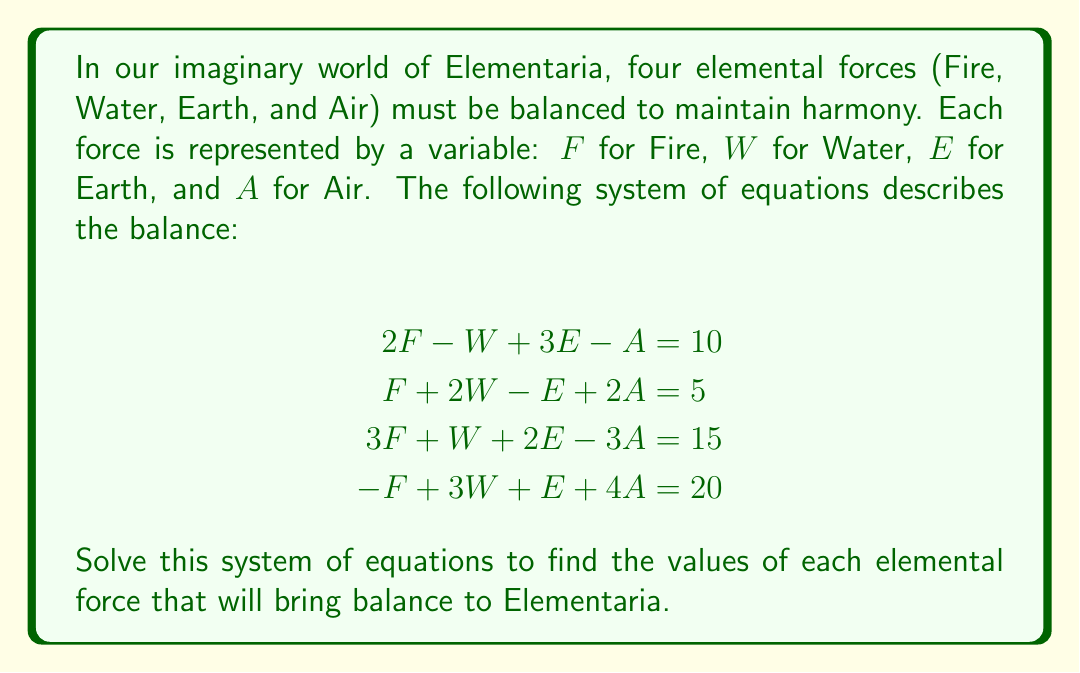Solve this math problem. Let's solve this system of equations using Gaussian elimination:

Step 1: Write the augmented matrix
$$\begin{bmatrix}
2 & -1 & 3 & -1 & 10 \\
1 & 2 & -1 & 2 & 5 \\
3 & 1 & 2 & -3 & 15 \\
-1 & 3 & 1 & 4 & 20
\end{bmatrix}$$

Step 2: Use row operations to transform the matrix into row echelon form

a) Multiply R1 by -1/2 and add to R2:
$$\begin{bmatrix}
2 & -1 & 3 & -1 & 10 \\
0 & 2.5 & -2.5 & 2.5 & 0 \\
3 & 1 & 2 & -3 & 15 \\
-1 & 3 & 1 & 4 & 20
\end{bmatrix}$$

b) Multiply R1 by -3/2 and add to R3:
$$\begin{bmatrix}
2 & -1 & 3 & -1 & 10 \\
0 & 2.5 & -2.5 & 2.5 & 0 \\
0 & 2.5 & -2.5 & -1.5 & 0 \\
-1 & 3 & 1 & 4 & 20
\end{bmatrix}$$

c) Multiply R1 by 1/2 and add to R4:
$$\begin{bmatrix}
2 & -1 & 3 & -1 & 10 \\
0 & 2.5 & -2.5 & 2.5 & 0 \\
0 & 2.5 & -2.5 & -1.5 & 0 \\
0 & 2.5 & 2.5 & 3.5 & 25
\end{bmatrix}$$

d) Multiply R2 by -1 and add to R3:
$$\begin{bmatrix}
2 & -1 & 3 & -1 & 10 \\
0 & 2.5 & -2.5 & 2.5 & 0 \\
0 & 0 & 0 & -4 & 0 \\
0 & 2.5 & 2.5 & 3.5 & 25
\end{bmatrix}$$

e) Multiply R2 by -1 and add to R4:
$$\begin{bmatrix}
2 & -1 & 3 & -1 & 10 \\
0 & 2.5 & -2.5 & 2.5 & 0 \\
0 & 0 & 0 & -4 & 0 \\
0 & 0 & 5 & 1 & 25
\end{bmatrix}$$

Step 3: Solve the system using back-substitution

From R3: $-4A = 0$, so $A = 0$

From R4: $5E + 1(0) = 25$, so $E = 5$

From R2: $2.5W - 2.5(5) + 2.5(0) = 0$, so $W = 5$

From R1: $2F - 1(5) + 3(5) - 1(0) = 10$, so $F = 5$

Therefore, the solution is $F = 5$, $W = 5$, $E = 5$, and $A = 0$.
Answer: $F = 5$, $W = 5$, $E = 5$, $A = 0$ 